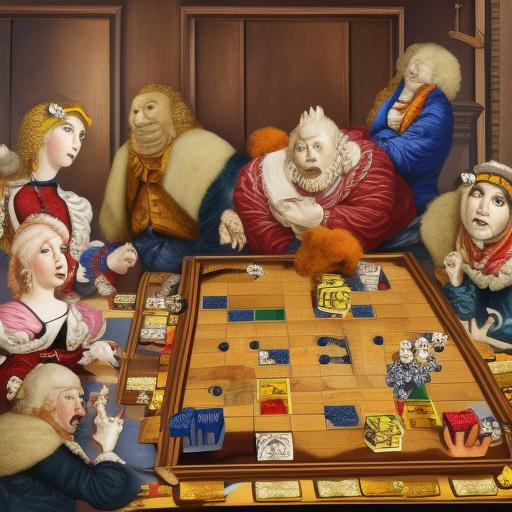Can you describe the attire of the individuals in the painting? Certainly! The individuals in the painting are dressed in lavish, historical attire. The women wear elegant gowns with decorative bodices, while the men are adorned in sophisticated garments that suggest a high social status, such as doublets, ruffs, and cloaks with fur trims. These fashion details enhance the painting's depiction of a refined, aristocratic gathering.  Are there any symbols or items in the painting that stand out to you? Indeed, the painting is rich in objects that could symbolize various themes. Besides the prominent chessboard at the center, there are also items like a book and a lyre on the side, which might represent knowledge and art. Furthermore, the intricate patterns on the clothing and furniture add another layer of symbolism, hinting at the careful attention to detail and the opulent lifestyle of the era. 